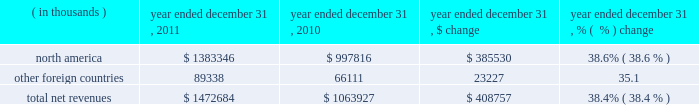2022 selling costs increased $ 25.0 million to $ 94.6 million in 2010 from $ 69.6 million in 2009 .
This increase was primarily due to higher personnel and other costs incurred for the continued expansion of our direct to consumer distribution channel and higher selling personnel costs , including increased expenses for our performance incentive plan as compared to the prior year .
As a percentage of net revenues , selling costs increased to 8.9% ( 8.9 % ) in 2010 from 8.1% ( 8.1 % ) in 2009 primarily due to higher personnel and other costs incurred for the continued expansion of our factory house stores .
2022 product innovation and supply chain costs increased $ 25.0 million to $ 96.8 million in 2010 from $ 71.8 million in 2009 primarily due to higher personnel costs for the design and sourcing of our expanding apparel , footwear and accessories lines and higher distribution facilities operating and personnel costs as compared to the prior year to support our growth in net revenues .
In addition , we incurred higher expenses for our performance incentive plan as compared to the prior year .
As a percentage of net revenues , product innovation and supply chain costs increased to 9.1% ( 9.1 % ) in 2010 from 8.4% ( 8.4 % ) in 2009 primarily due to the items noted above .
2022 corporate services costs increased $ 24.0 million to $ 98.6 million in 2010 from $ 74.6 million in 2009 .
This increase was attributable primarily to higher corporate facility costs , information technology initiatives and corporate personnel costs , including increased expenses for our performance incentive plan as compared to the prior year .
As a percentage of net revenues , corporate services costs increased to 9.3% ( 9.3 % ) in 2010 from 8.7% ( 8.7 % ) in 2009 primarily due to the items noted above .
Income from operations increased $ 27.1 million , or 31.8% ( 31.8 % ) , to $ 112.4 million in 2010 from $ 85.3 million in 2009 .
Income from operations as a percentage of net revenues increased to 10.6% ( 10.6 % ) in 2010 from 10.0% ( 10.0 % ) in 2009 .
This increase was a result of the items discussed above .
Interest expense , net remained unchanged at $ 2.3 million in 2010 and 2009 .
Other expense , net increased $ 0.7 million to $ 1.2 million in 2010 from $ 0.5 million in 2009 .
The increase in 2010 was due to higher net losses on the combined foreign currency exchange rate changes on transactions denominated in the euro and canadian dollar and our derivative financial instruments as compared to 2009 .
Provision for income taxes increased $ 4.8 million to $ 40.4 million in 2010 from $ 35.6 million in 2009 .
Our effective tax rate was 37.1% ( 37.1 % ) in 2010 compared to 43.2% ( 43.2 % ) in 2009 , primarily due to tax planning strategies and federal and state tax credits reducing the effective tax rate , partially offset by a valuation allowance recorded against our foreign net operating loss carryforward .
Segment results of operations year ended december 31 , 2011 compared to year ended december 31 , 2010 net revenues by geographic region are summarized below: .
Net revenues in our north american operating segment increased $ 385.5 million to $ 1383.3 million in 2011 from $ 997.8 million in 2010 primarily due to the items discussed above in the consolidated results of operations .
Net revenues in other foreign countries increased by $ 23.2 million to $ 89.3 million in 2011 from $ 66.1 million in 2010 primarily due to footwear shipments to our dome licensee , as well as unit sales growth to our distributors in our latin american operating segment. .
What was the percent of the north america to the total revenues? 
Rationale: the total revenues were made of 93.4% sales from north america
Computations: (1383346 / 1472684)
Answer: 0.93934. 